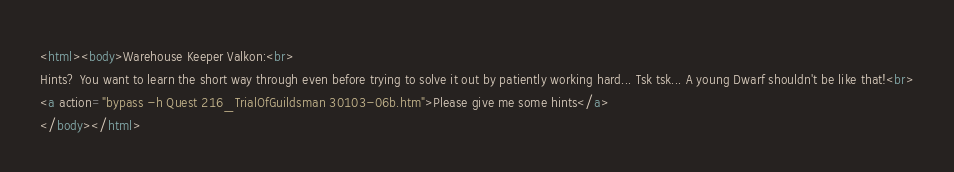Convert code to text. <code><loc_0><loc_0><loc_500><loc_500><_HTML_><html><body>Warehouse Keeper Valkon:<br>
Hints? You want to learn the short way through even before trying to solve it out by patiently working hard... Tsk tsk... A young Dwarf shouldn't be like that!<br>
<a action="bypass -h Quest 216_TrialOfGuildsman 30103-06b.htm">Please give me some hints</a>
</body></html>
</code> 